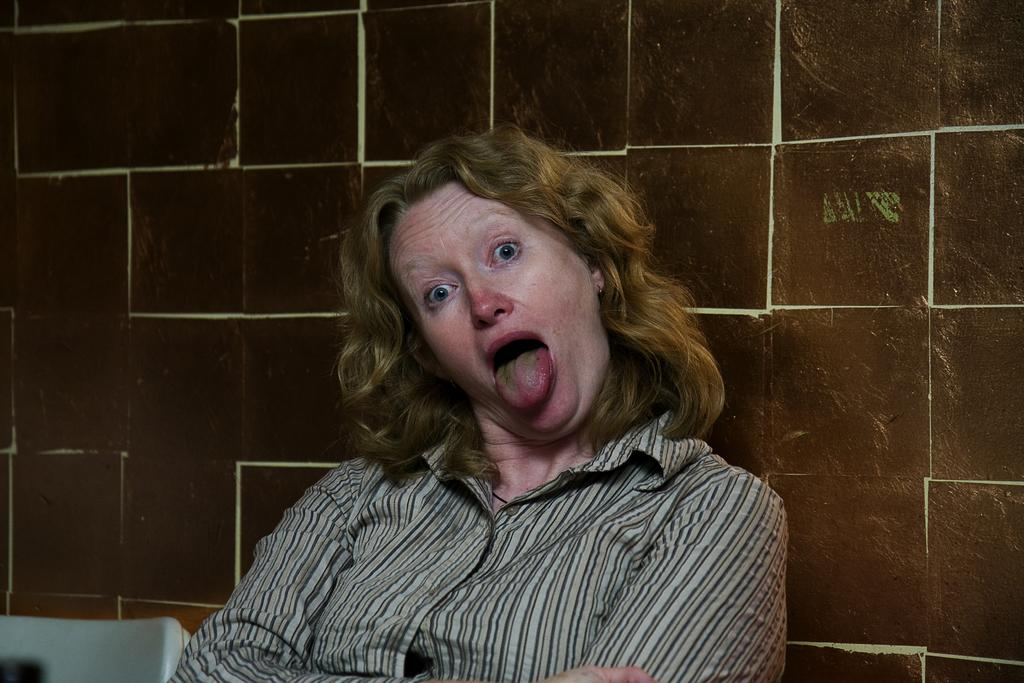What can be seen in the image? There is a person in the image. Can you describe the object in the bottom left corner of the image? There is an object in the bottom left corner of the image, but its specific details are not clear from the provided facts. What is visible in the background of the image? There is a wall in the background of the image. What type of zinc is being used by the person in the image? There is no mention of zinc or any related activity in the image, so it cannot be determined from the provided facts. How much hair does the person in the image have? The provided facts do not give any information about the person's hair, so it cannot be determined from the image. 